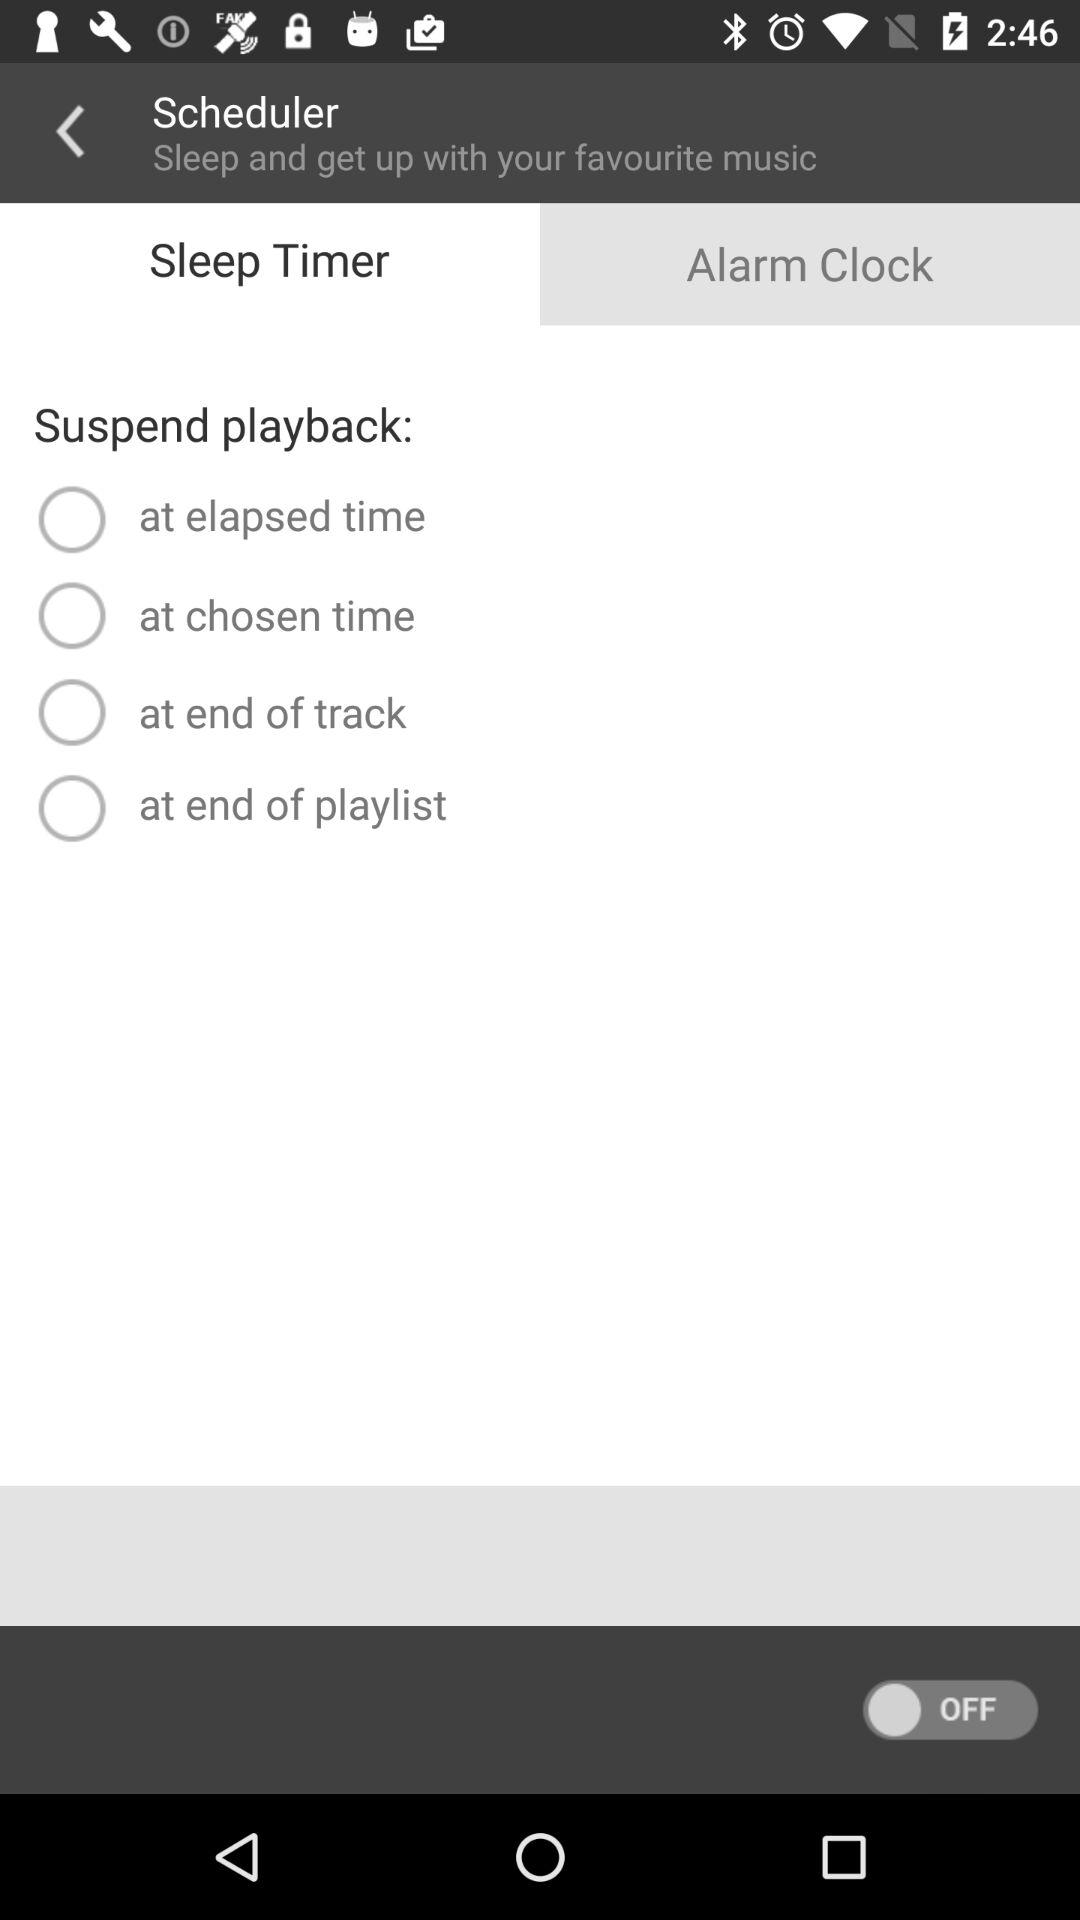How many choices do I have to suspend playback?
Answer the question using a single word or phrase. 4 